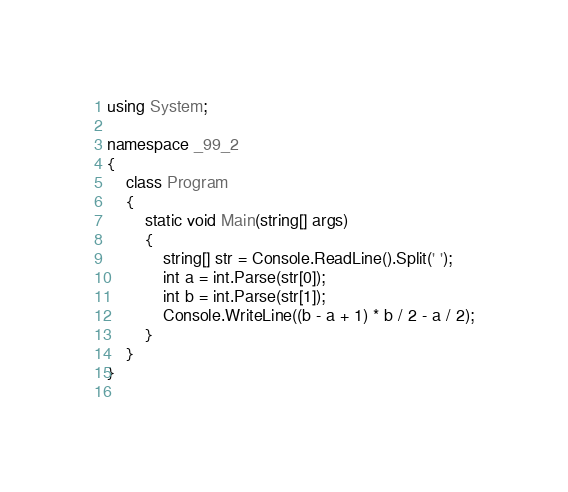Convert code to text. <code><loc_0><loc_0><loc_500><loc_500><_C#_>using System;

namespace _99_2
{
    class Program
    {
        static void Main(string[] args)
        {
			string[] str = Console.ReadLine().Split(' ');
			int a = int.Parse(str[0]);
			int b = int.Parse(str[1]);
			Console.WriteLine((b - a + 1) * b / 2 - a / 2);
		}
    }
}
 </code> 